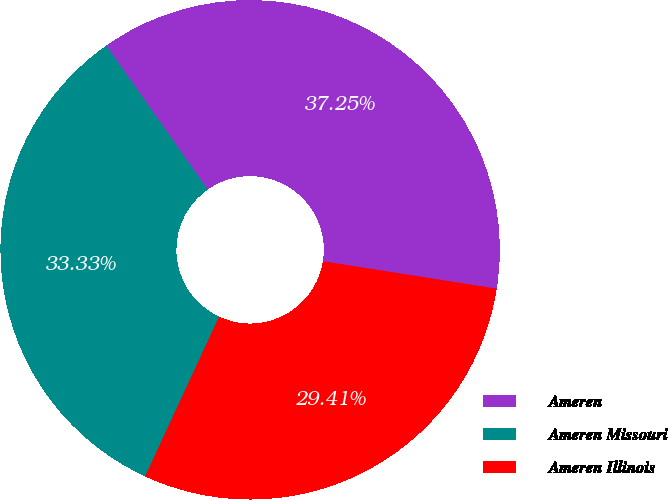Convert chart to OTSL. <chart><loc_0><loc_0><loc_500><loc_500><pie_chart><fcel>Ameren<fcel>Ameren Missouri<fcel>Ameren Illinois<nl><fcel>37.25%<fcel>33.33%<fcel>29.41%<nl></chart> 